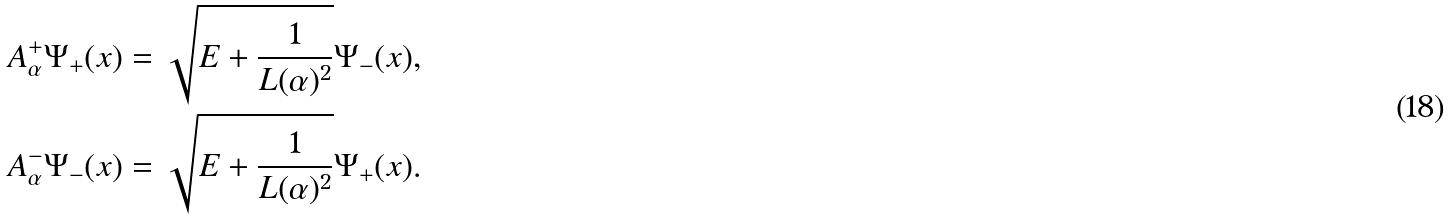<formula> <loc_0><loc_0><loc_500><loc_500>A _ { \alpha } ^ { + } \Psi _ { + } ( x ) & = \sqrt { E + \frac { 1 } { L ( \alpha ) ^ { 2 } } } \Psi _ { - } ( x ) , \\ A _ { \alpha } ^ { - } \Psi _ { - } ( x ) & = \sqrt { E + \frac { 1 } { L ( \alpha ) ^ { 2 } } } \Psi _ { + } ( x ) .</formula> 